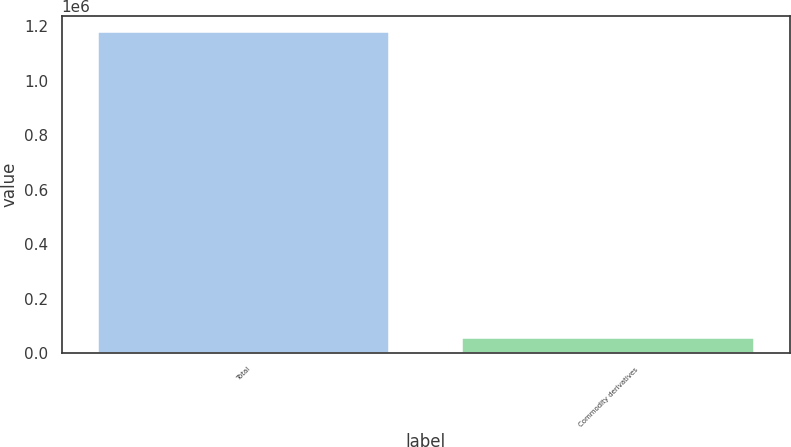<chart> <loc_0><loc_0><loc_500><loc_500><bar_chart><fcel>Total<fcel>Commodity derivatives<nl><fcel>1.17826e+06<fcel>54307<nl></chart> 